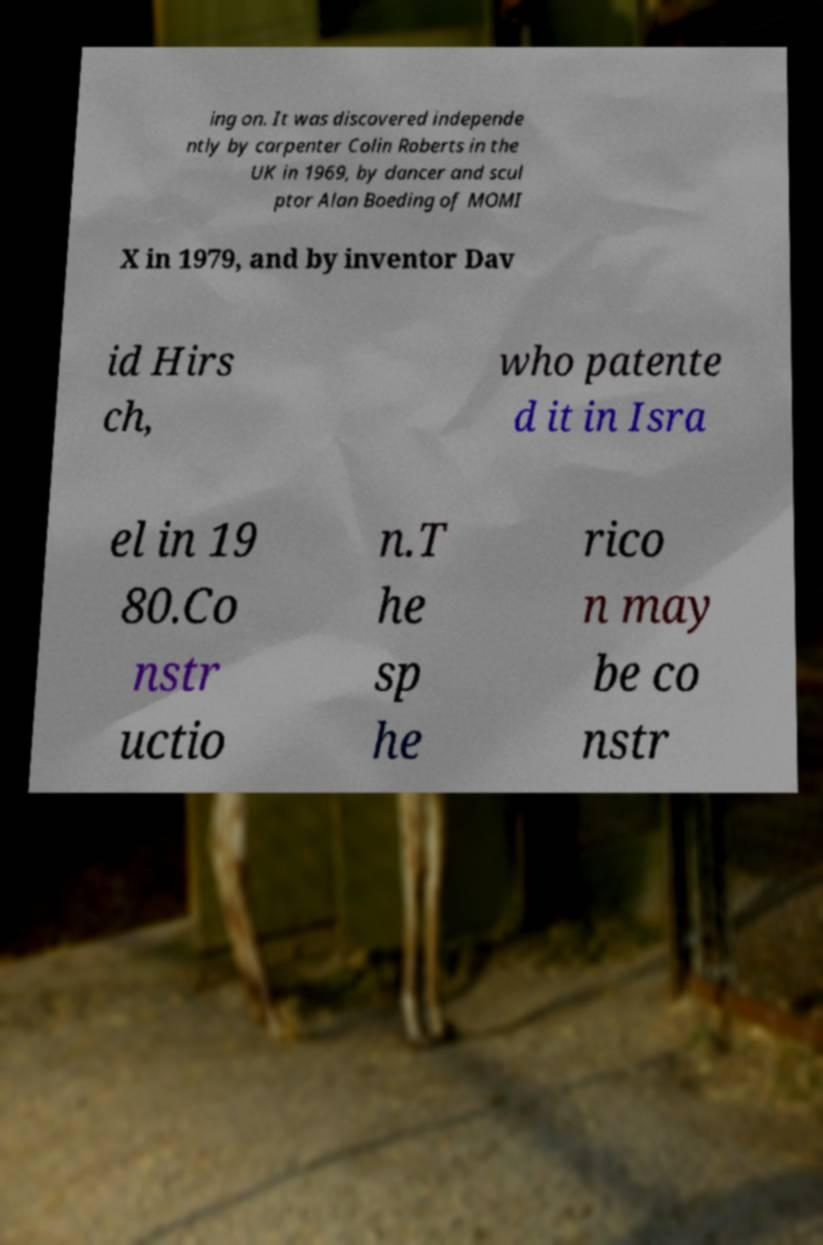I need the written content from this picture converted into text. Can you do that? ing on. It was discovered independe ntly by carpenter Colin Roberts in the UK in 1969, by dancer and scul ptor Alan Boeding of MOMI X in 1979, and by inventor Dav id Hirs ch, who patente d it in Isra el in 19 80.Co nstr uctio n.T he sp he rico n may be co nstr 